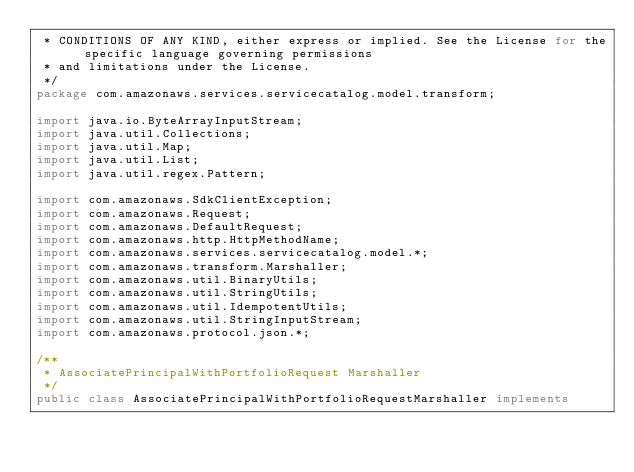<code> <loc_0><loc_0><loc_500><loc_500><_Java_> * CONDITIONS OF ANY KIND, either express or implied. See the License for the specific language governing permissions
 * and limitations under the License.
 */
package com.amazonaws.services.servicecatalog.model.transform;

import java.io.ByteArrayInputStream;
import java.util.Collections;
import java.util.Map;
import java.util.List;
import java.util.regex.Pattern;

import com.amazonaws.SdkClientException;
import com.amazonaws.Request;
import com.amazonaws.DefaultRequest;
import com.amazonaws.http.HttpMethodName;
import com.amazonaws.services.servicecatalog.model.*;
import com.amazonaws.transform.Marshaller;
import com.amazonaws.util.BinaryUtils;
import com.amazonaws.util.StringUtils;
import com.amazonaws.util.IdempotentUtils;
import com.amazonaws.util.StringInputStream;
import com.amazonaws.protocol.json.*;

/**
 * AssociatePrincipalWithPortfolioRequest Marshaller
 */
public class AssociatePrincipalWithPortfolioRequestMarshaller implements</code> 